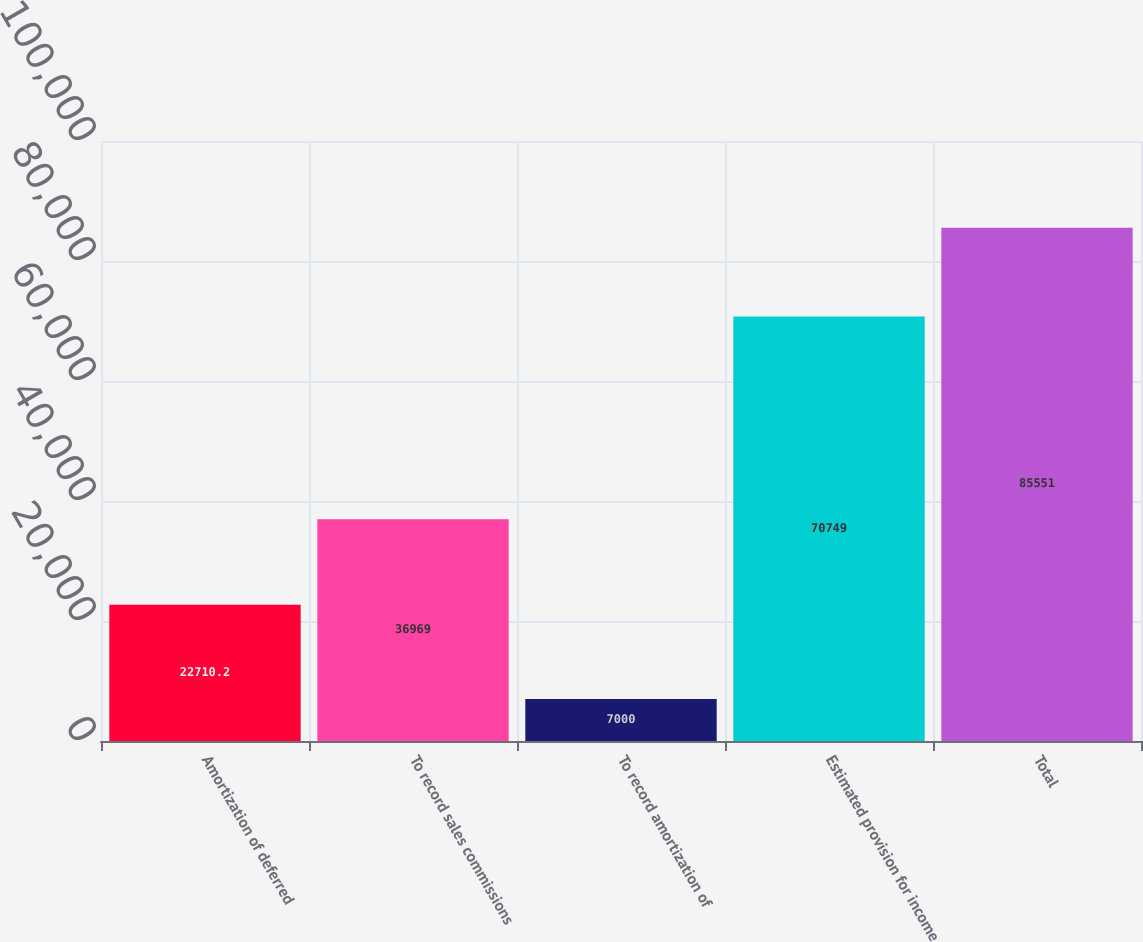Convert chart to OTSL. <chart><loc_0><loc_0><loc_500><loc_500><bar_chart><fcel>Amortization of deferred<fcel>To record sales commissions<fcel>To record amortization of<fcel>Estimated provision for income<fcel>Total<nl><fcel>22710.2<fcel>36969<fcel>7000<fcel>70749<fcel>85551<nl></chart> 